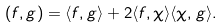Convert formula to latex. <formula><loc_0><loc_0><loc_500><loc_500>( f , g ) = \langle f , g \rangle + 2 \langle f , \chi \rangle \langle \chi , g \rangle .</formula> 